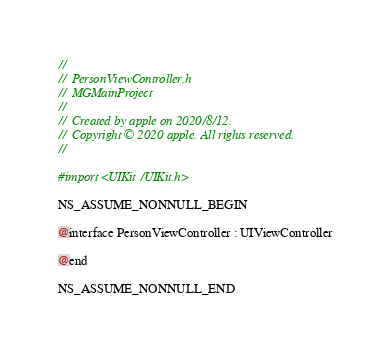<code> <loc_0><loc_0><loc_500><loc_500><_C_>//
//  PersonViewController.h
//  MGMainProject
//
//  Created by apple on 2020/8/12.
//  Copyright © 2020 apple. All rights reserved.
//

#import <UIKit/UIKit.h>

NS_ASSUME_NONNULL_BEGIN

@interface PersonViewController : UIViewController

@end

NS_ASSUME_NONNULL_END
</code> 